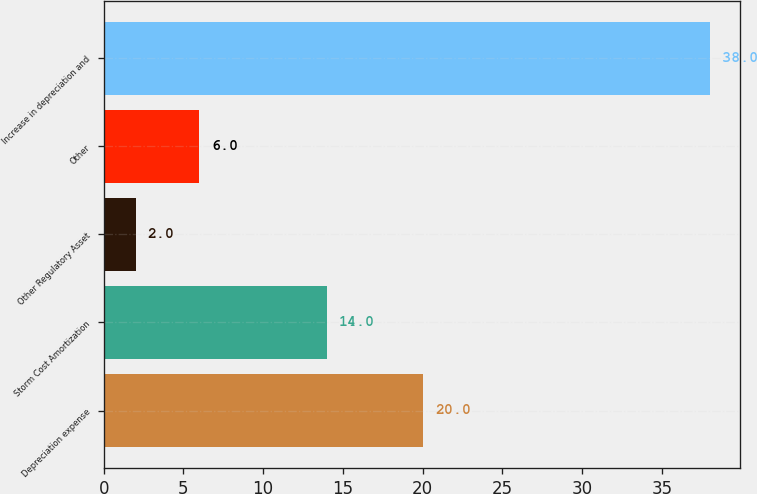Convert chart to OTSL. <chart><loc_0><loc_0><loc_500><loc_500><bar_chart><fcel>Depreciation expense<fcel>Storm Cost Amortization<fcel>Other Regulatory Asset<fcel>Other<fcel>Increase in depreciation and<nl><fcel>20<fcel>14<fcel>2<fcel>6<fcel>38<nl></chart> 